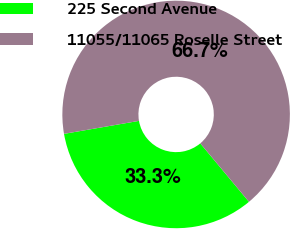<chart> <loc_0><loc_0><loc_500><loc_500><pie_chart><fcel>225 Second Avenue<fcel>11055/11065 Roselle Street<nl><fcel>33.33%<fcel>66.67%<nl></chart> 